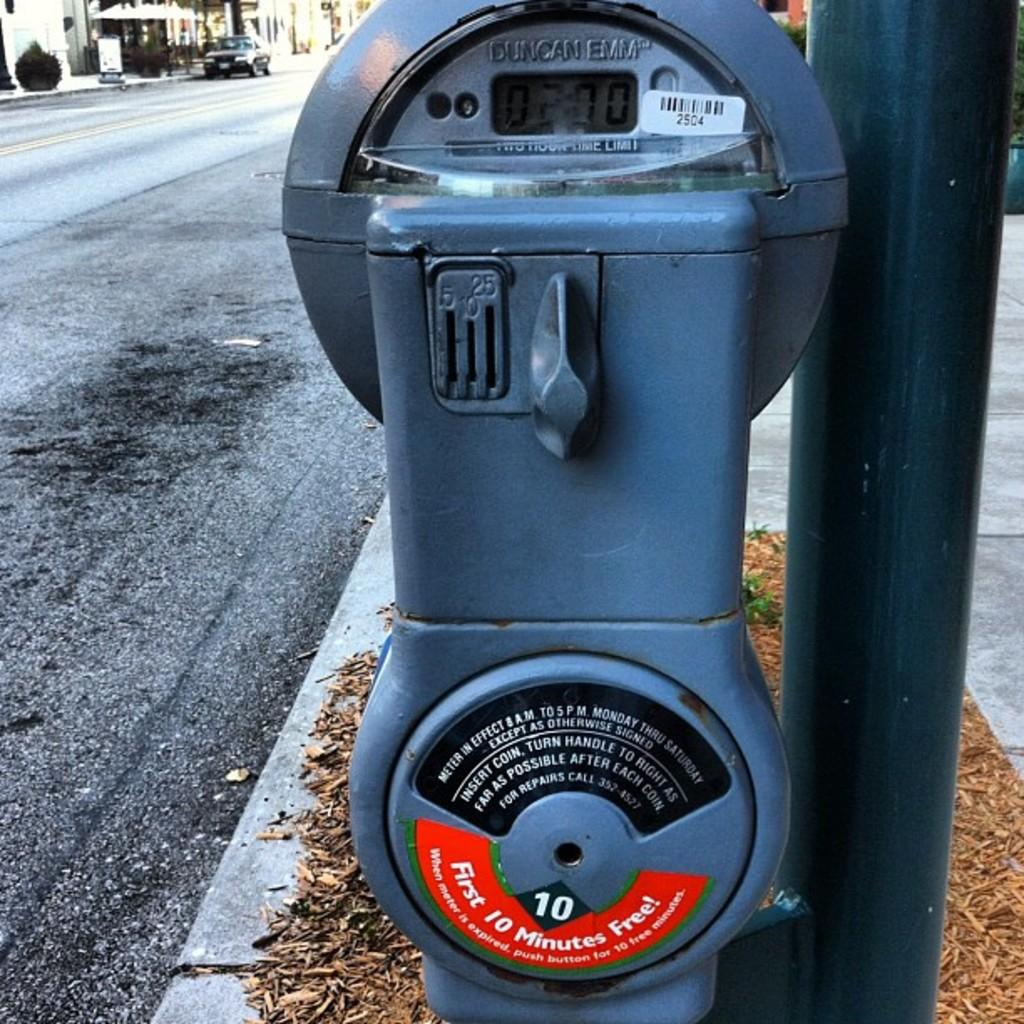<image>
Summarize the visual content of the image. A sticker on a parking meter promises that the first 10 minutes are free. 